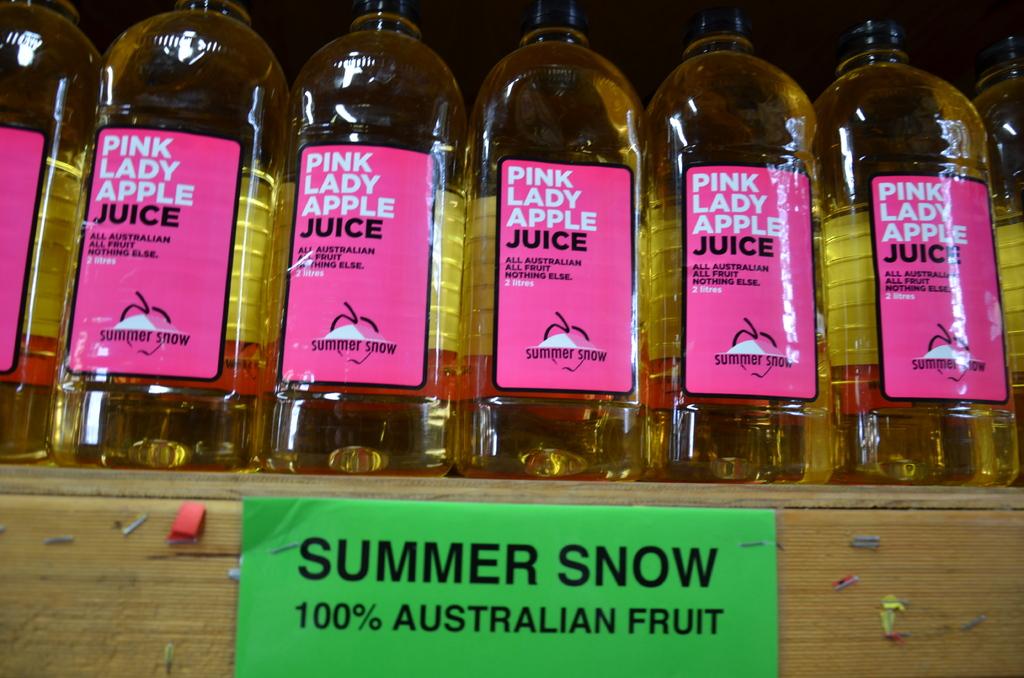What kind of drink is this?
Provide a succinct answer. Apple juice. How much juice is in the bottles?
Offer a very short reply. 2 litres. 